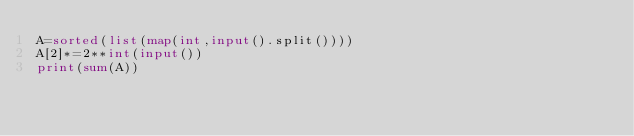<code> <loc_0><loc_0><loc_500><loc_500><_Python_>A=sorted(list(map(int,input().split())))
A[2]*=2**int(input())
print(sum(A))</code> 